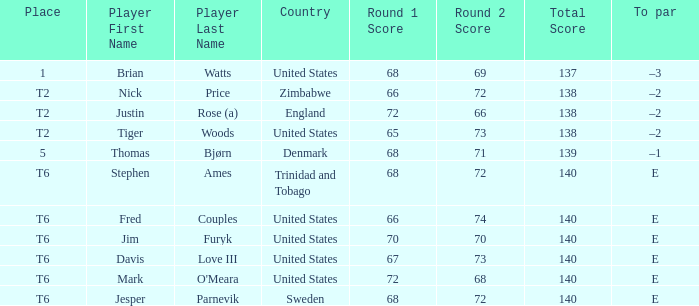For the player who achieved 68-69=137, what was their to par? –3. 